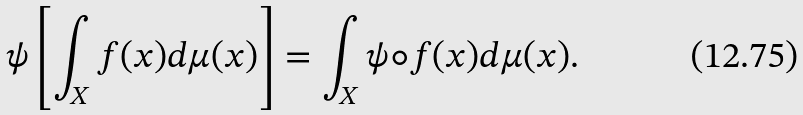Convert formula to latex. <formula><loc_0><loc_0><loc_500><loc_500>\psi \left [ \int _ { X } f ( x ) d \mu ( x ) \right ] = \int _ { X } \psi \circ f ( x ) d \mu ( x ) .</formula> 